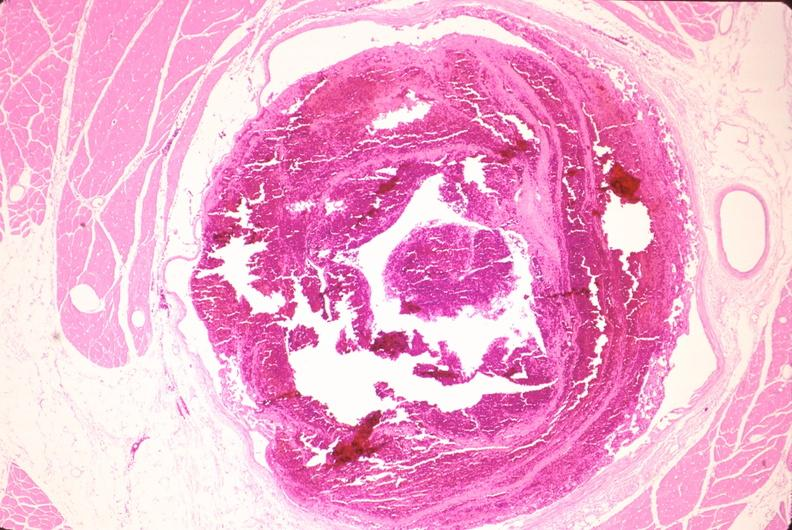s polycystic disease present?
Answer the question using a single word or phrase. No 